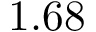Convert formula to latex. <formula><loc_0><loc_0><loc_500><loc_500>1 . 6 8</formula> 